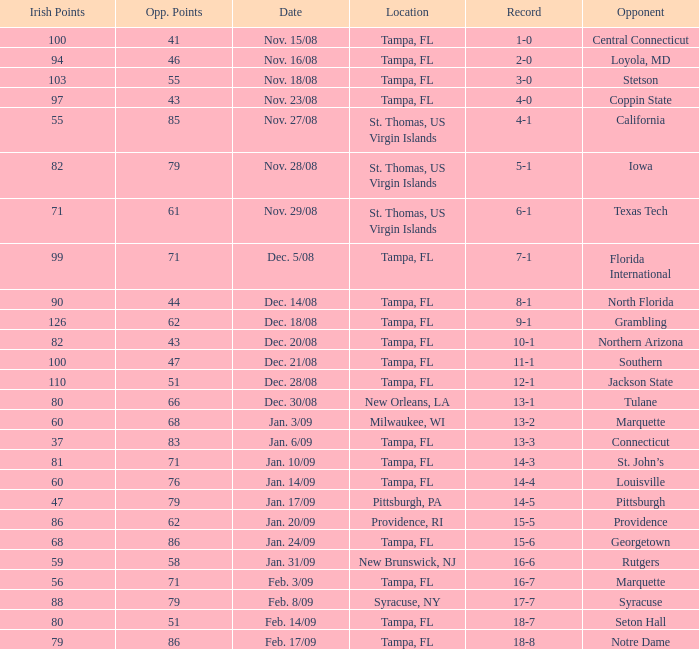Could you parse the entire table? {'header': ['Irish Points', 'Opp. Points', 'Date', 'Location', 'Record', 'Opponent'], 'rows': [['100', '41', 'Nov. 15/08', 'Tampa, FL', '1-0', 'Central Connecticut'], ['94', '46', 'Nov. 16/08', 'Tampa, FL', '2-0', 'Loyola, MD'], ['103', '55', 'Nov. 18/08', 'Tampa, FL', '3-0', 'Stetson'], ['97', '43', 'Nov. 23/08', 'Tampa, FL', '4-0', 'Coppin State'], ['55', '85', 'Nov. 27/08', 'St. Thomas, US Virgin Islands', '4-1', 'California'], ['82', '79', 'Nov. 28/08', 'St. Thomas, US Virgin Islands', '5-1', 'Iowa'], ['71', '61', 'Nov. 29/08', 'St. Thomas, US Virgin Islands', '6-1', 'Texas Tech'], ['99', '71', 'Dec. 5/08', 'Tampa, FL', '7-1', 'Florida International'], ['90', '44', 'Dec. 14/08', 'Tampa, FL', '8-1', 'North Florida'], ['126', '62', 'Dec. 18/08', 'Tampa, FL', '9-1', 'Grambling'], ['82', '43', 'Dec. 20/08', 'Tampa, FL', '10-1', 'Northern Arizona'], ['100', '47', 'Dec. 21/08', 'Tampa, FL', '11-1', 'Southern'], ['110', '51', 'Dec. 28/08', 'Tampa, FL', '12-1', 'Jackson State'], ['80', '66', 'Dec. 30/08', 'New Orleans, LA', '13-1', 'Tulane'], ['60', '68', 'Jan. 3/09', 'Milwaukee, WI', '13-2', 'Marquette'], ['37', '83', 'Jan. 6/09', 'Tampa, FL', '13-3', 'Connecticut'], ['81', '71', 'Jan. 10/09', 'Tampa, FL', '14-3', 'St. John’s'], ['60', '76', 'Jan. 14/09', 'Tampa, FL', '14-4', 'Louisville'], ['47', '79', 'Jan. 17/09', 'Pittsburgh, PA', '14-5', 'Pittsburgh'], ['86', '62', 'Jan. 20/09', 'Providence, RI', '15-5', 'Providence'], ['68', '86', 'Jan. 24/09', 'Tampa, FL', '15-6', 'Georgetown'], ['59', '58', 'Jan. 31/09', 'New Brunswick, NJ', '16-6', 'Rutgers'], ['56', '71', 'Feb. 3/09', 'Tampa, FL', '16-7', 'Marquette'], ['88', '79', 'Feb. 8/09', 'Syracuse, NY', '17-7', 'Syracuse'], ['80', '51', 'Feb. 14/09', 'Tampa, FL', '18-7', 'Seton Hall'], ['79', '86', 'Feb. 17/09', 'Tampa, FL', '18-8', 'Notre Dame']]} What is the record where the locaiton is tampa, fl and the opponent is louisville? 14-4. 